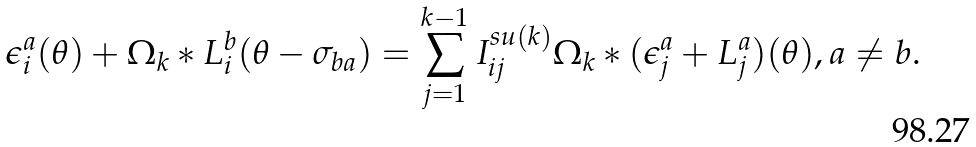<formula> <loc_0><loc_0><loc_500><loc_500>\epsilon _ { i } ^ { a } ( \theta ) + \Omega _ { k } \ast L _ { i } ^ { b } ( \theta - \sigma _ { b a } ) = \sum _ { j = 1 } ^ { k - 1 } I _ { i j } ^ { s u ( k ) } \Omega _ { k } \ast ( \epsilon _ { j } ^ { a } + L _ { j } ^ { a } ) ( \theta ) , a \neq b .</formula> 